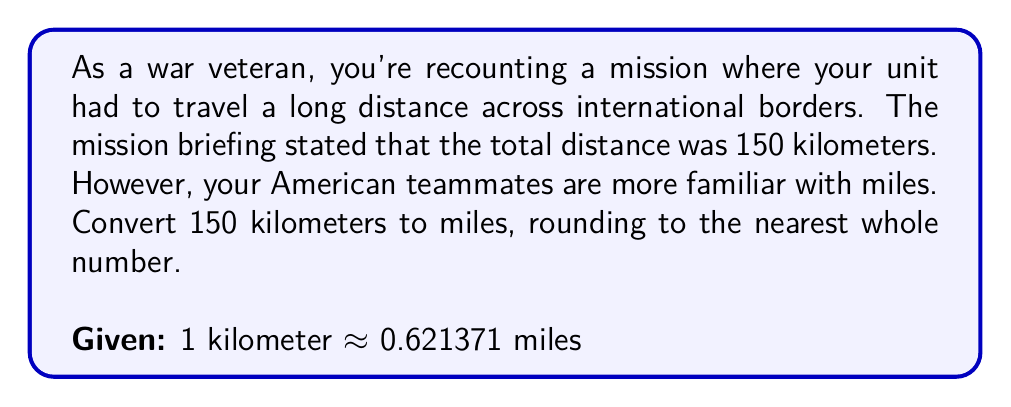Provide a solution to this math problem. To convert kilometers to miles, we need to multiply the number of kilometers by the conversion factor:

$$ 150 \text{ km} \times 0.621371 \text{ miles/km} $$

Let's perform this calculation step-by-step:

1) First, multiply 150 by 0.621371:
   $$ 150 \times 0.621371 = 93.20565 $$

2) This gives us 93.20565 miles.

3) The question asks to round to the nearest whole number.
   93.20565 is closer to 93 than to 94, so we round down.

Therefore, 150 kilometers is approximately 93 miles when rounded to the nearest whole number.
Answer: 93 miles 